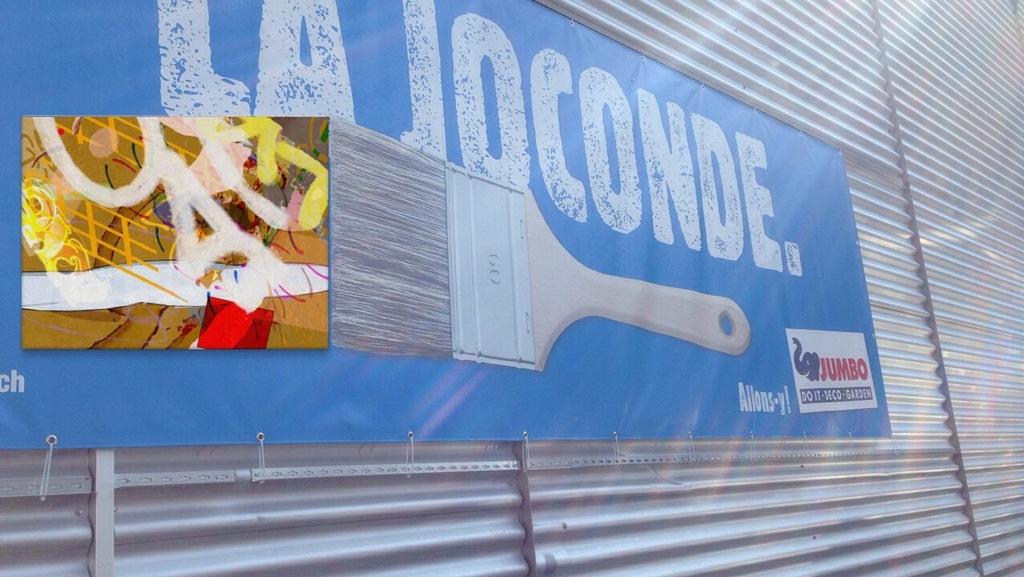What name is the banner advertising?
Offer a terse response. La joconde. What is advertisement on the bottom right?
Your response must be concise. Jumbo. 